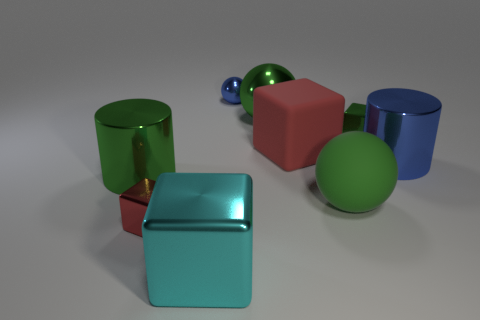Subtract all cylinders. How many objects are left? 7 Subtract all big cyan objects. Subtract all shiny things. How many objects are left? 1 Add 5 big spheres. How many big spheres are left? 7 Add 2 green metallic cylinders. How many green metallic cylinders exist? 3 Subtract 0 red spheres. How many objects are left? 9 